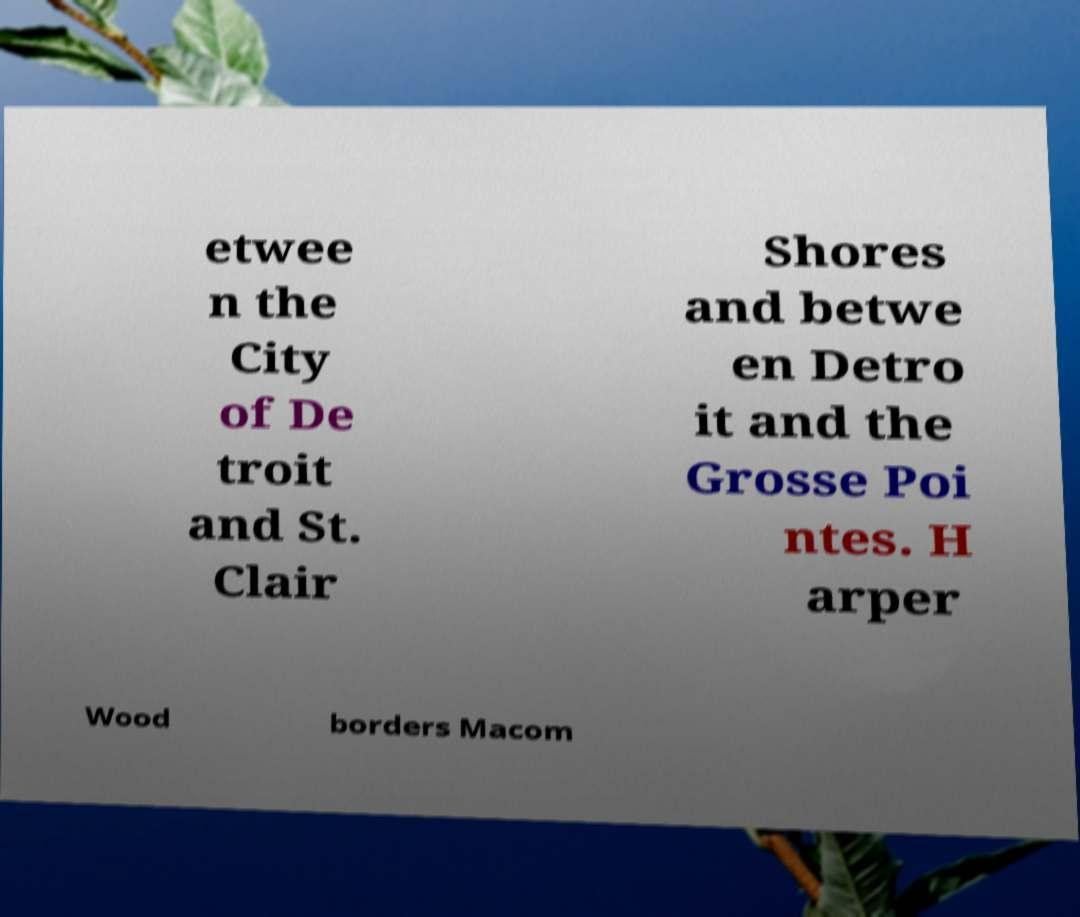There's text embedded in this image that I need extracted. Can you transcribe it verbatim? etwee n the City of De troit and St. Clair Shores and betwe en Detro it and the Grosse Poi ntes. H arper Wood borders Macom 